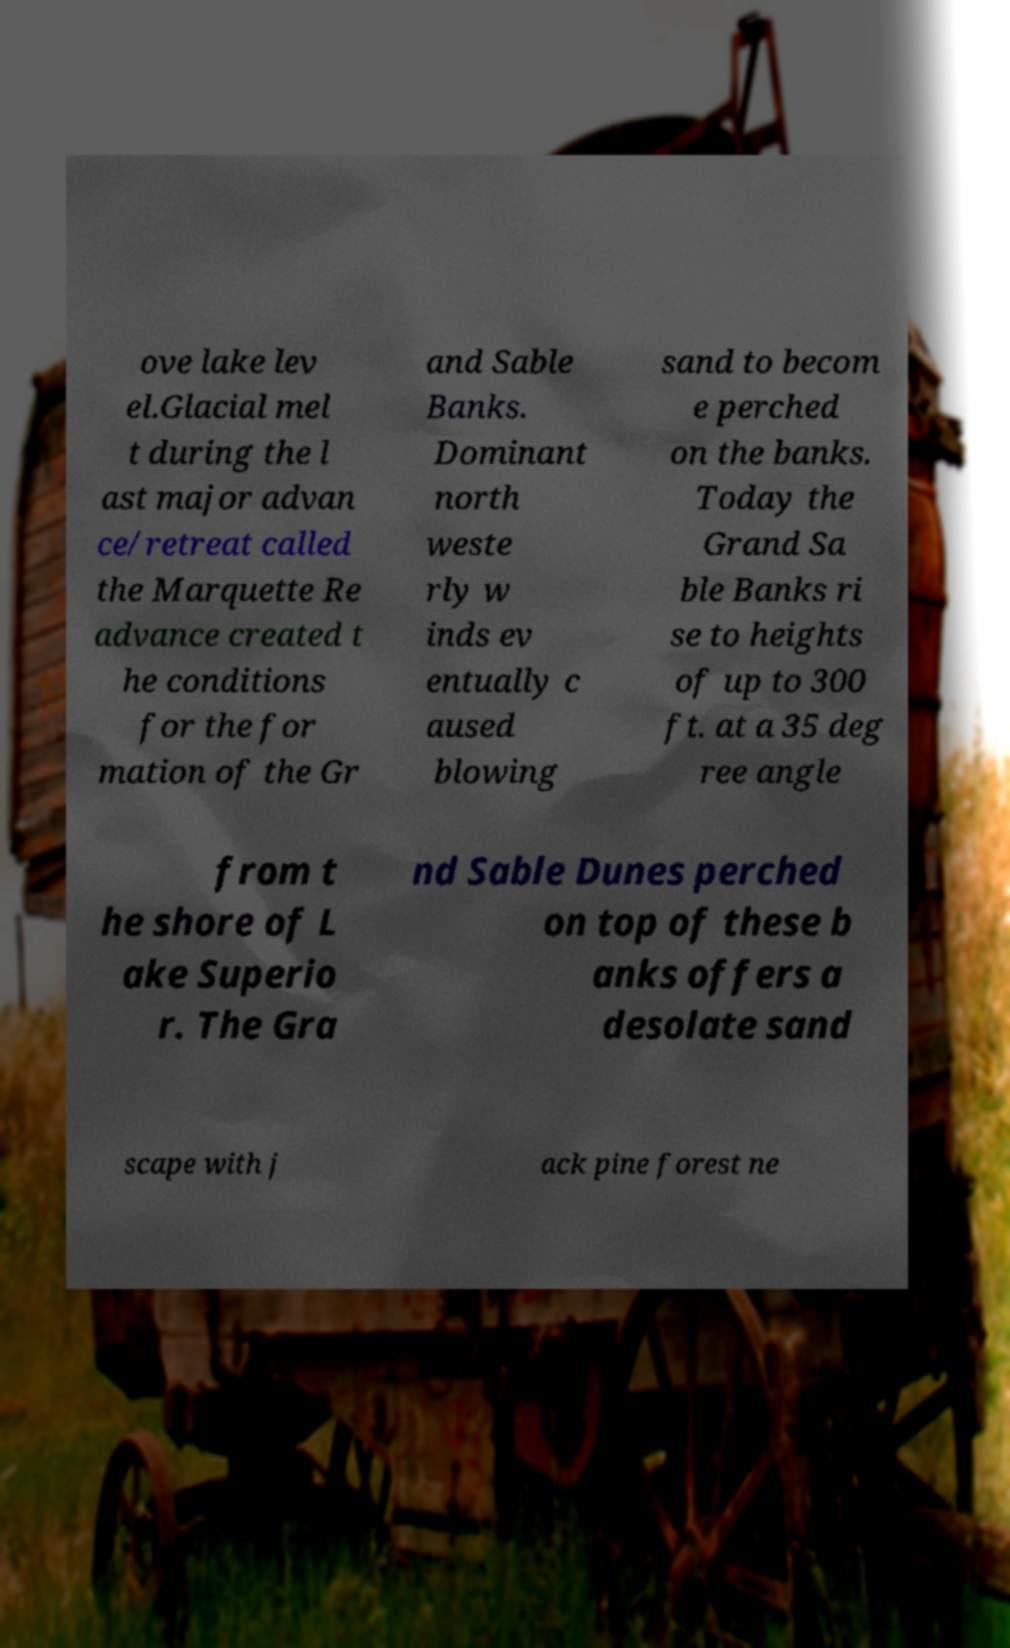For documentation purposes, I need the text within this image transcribed. Could you provide that? ove lake lev el.Glacial mel t during the l ast major advan ce/retreat called the Marquette Re advance created t he conditions for the for mation of the Gr and Sable Banks. Dominant north weste rly w inds ev entually c aused blowing sand to becom e perched on the banks. Today the Grand Sa ble Banks ri se to heights of up to 300 ft. at a 35 deg ree angle from t he shore of L ake Superio r. The Gra nd Sable Dunes perched on top of these b anks offers a desolate sand scape with j ack pine forest ne 